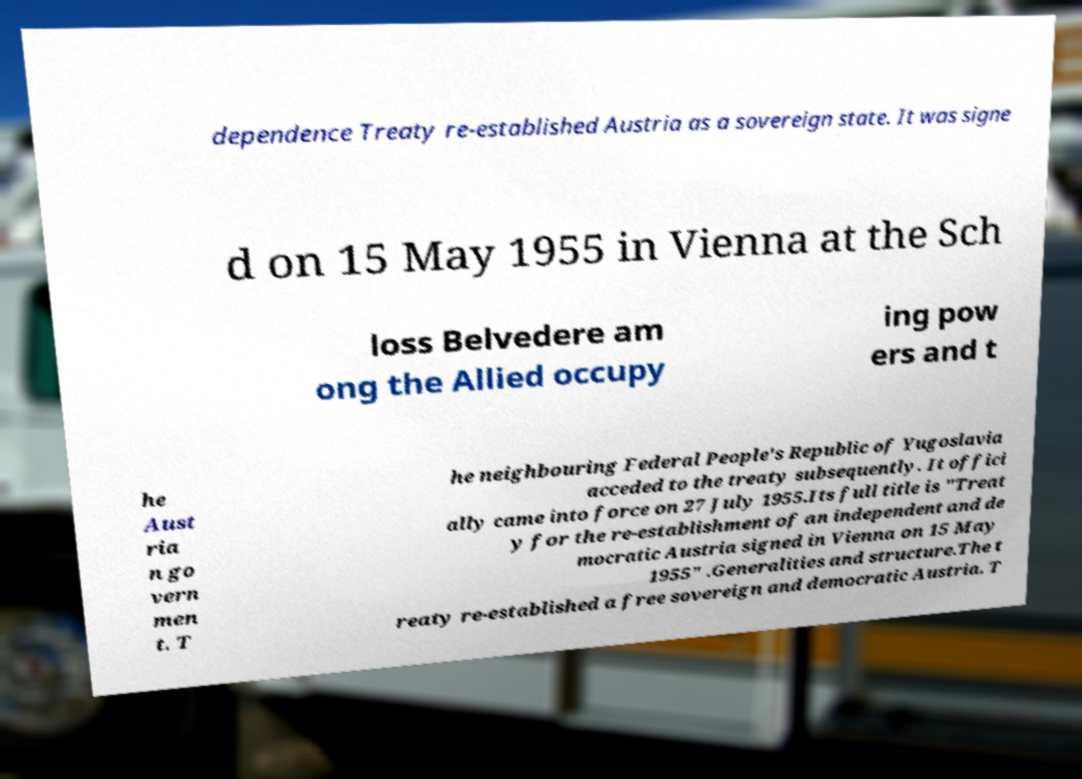There's text embedded in this image that I need extracted. Can you transcribe it verbatim? dependence Treaty re-established Austria as a sovereign state. It was signe d on 15 May 1955 in Vienna at the Sch loss Belvedere am ong the Allied occupy ing pow ers and t he Aust ria n go vern men t. T he neighbouring Federal People's Republic of Yugoslavia acceded to the treaty subsequently. It offici ally came into force on 27 July 1955.Its full title is "Treat y for the re-establishment of an independent and de mocratic Austria signed in Vienna on 15 May 1955" .Generalities and structure.The t reaty re-established a free sovereign and democratic Austria. T 